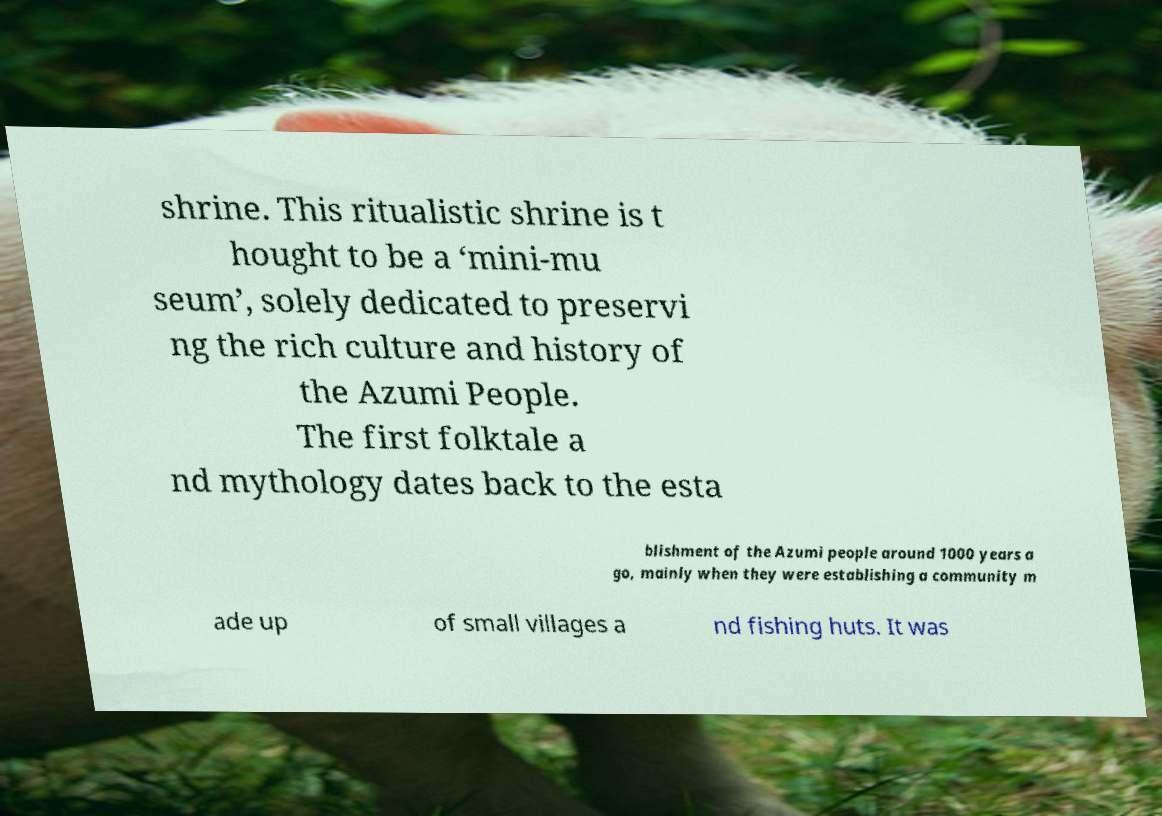Can you read and provide the text displayed in the image?This photo seems to have some interesting text. Can you extract and type it out for me? shrine. This ritualistic shrine is t hought to be a ‘mini-mu seum’, solely dedicated to preservi ng the rich culture and history of the Azumi People. The first folktale a nd mythology dates back to the esta blishment of the Azumi people around 1000 years a go, mainly when they were establishing a community m ade up of small villages a nd fishing huts. It was 